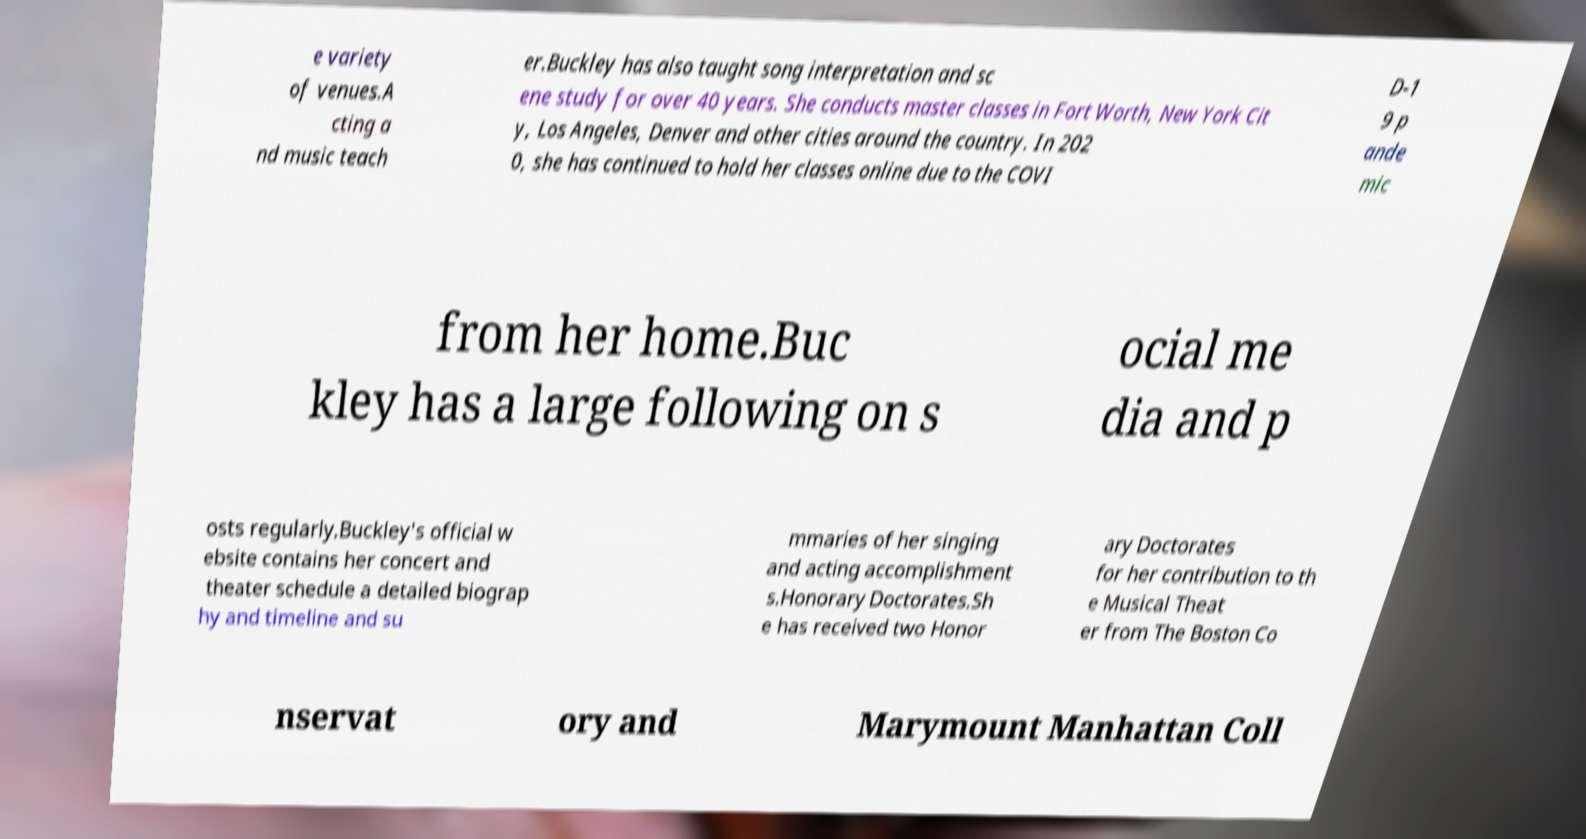Could you extract and type out the text from this image? e variety of venues.A cting a nd music teach er.Buckley has also taught song interpretation and sc ene study for over 40 years. She conducts master classes in Fort Worth, New York Cit y, Los Angeles, Denver and other cities around the country. In 202 0, she has continued to hold her classes online due to the COVI D-1 9 p ande mic from her home.Buc kley has a large following on s ocial me dia and p osts regularly.Buckley's official w ebsite contains her concert and theater schedule a detailed biograp hy and timeline and su mmaries of her singing and acting accomplishment s.Honorary Doctorates.Sh e has received two Honor ary Doctorates for her contribution to th e Musical Theat er from The Boston Co nservat ory and Marymount Manhattan Coll 